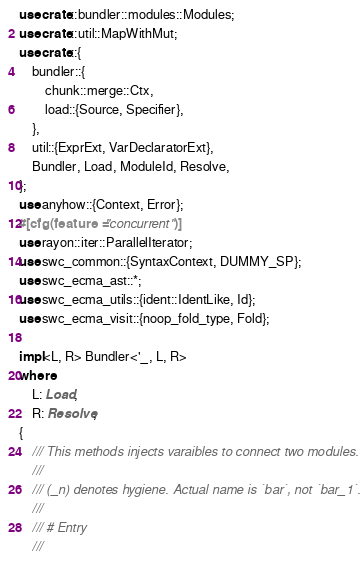Convert code to text. <code><loc_0><loc_0><loc_500><loc_500><_Rust_>use crate::bundler::modules::Modules;
use crate::util::MapWithMut;
use crate::{
    bundler::{
        chunk::merge::Ctx,
        load::{Source, Specifier},
    },
    util::{ExprExt, VarDeclaratorExt},
    Bundler, Load, ModuleId, Resolve,
};
use anyhow::{Context, Error};
#[cfg(feature = "concurrent")]
use rayon::iter::ParallelIterator;
use swc_common::{SyntaxContext, DUMMY_SP};
use swc_ecma_ast::*;
use swc_ecma_utils::{ident::IdentLike, Id};
use swc_ecma_visit::{noop_fold_type, Fold};

impl<L, R> Bundler<'_, L, R>
where
    L: Load,
    R: Resolve,
{
    /// This methods injects varaibles to connect two modules.
    ///
    /// (_n) denotes hygiene. Actual name is `bar`, not `bar_1`.
    ///
    /// # Entry
    ///</code> 